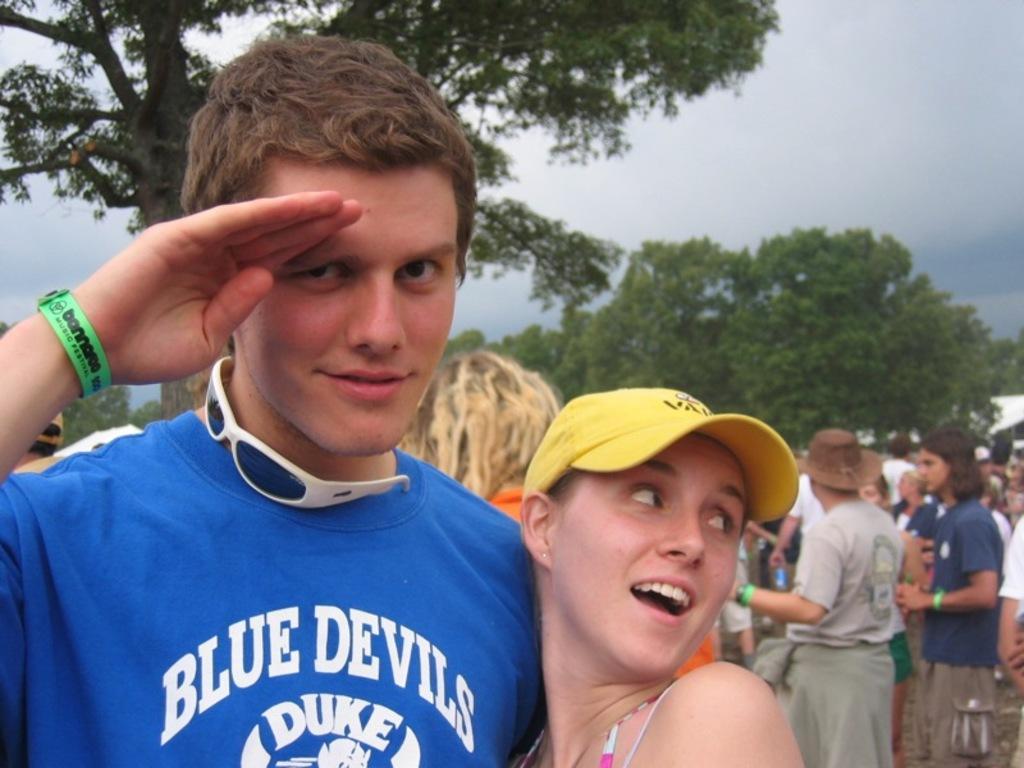Could you give a brief overview of what you see in this image? Here is the man and woman standing. This man is saluting. There are group of people standing. These are the trees with branches and leaves. 